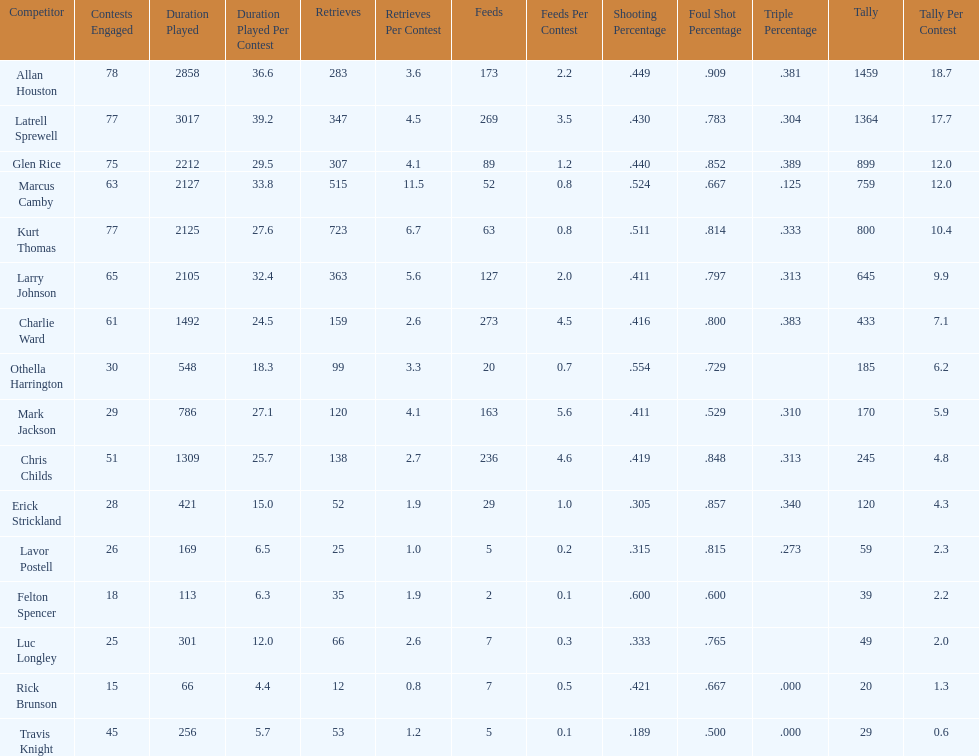Who scored more points, larry johnson or charlie ward? Larry Johnson. 